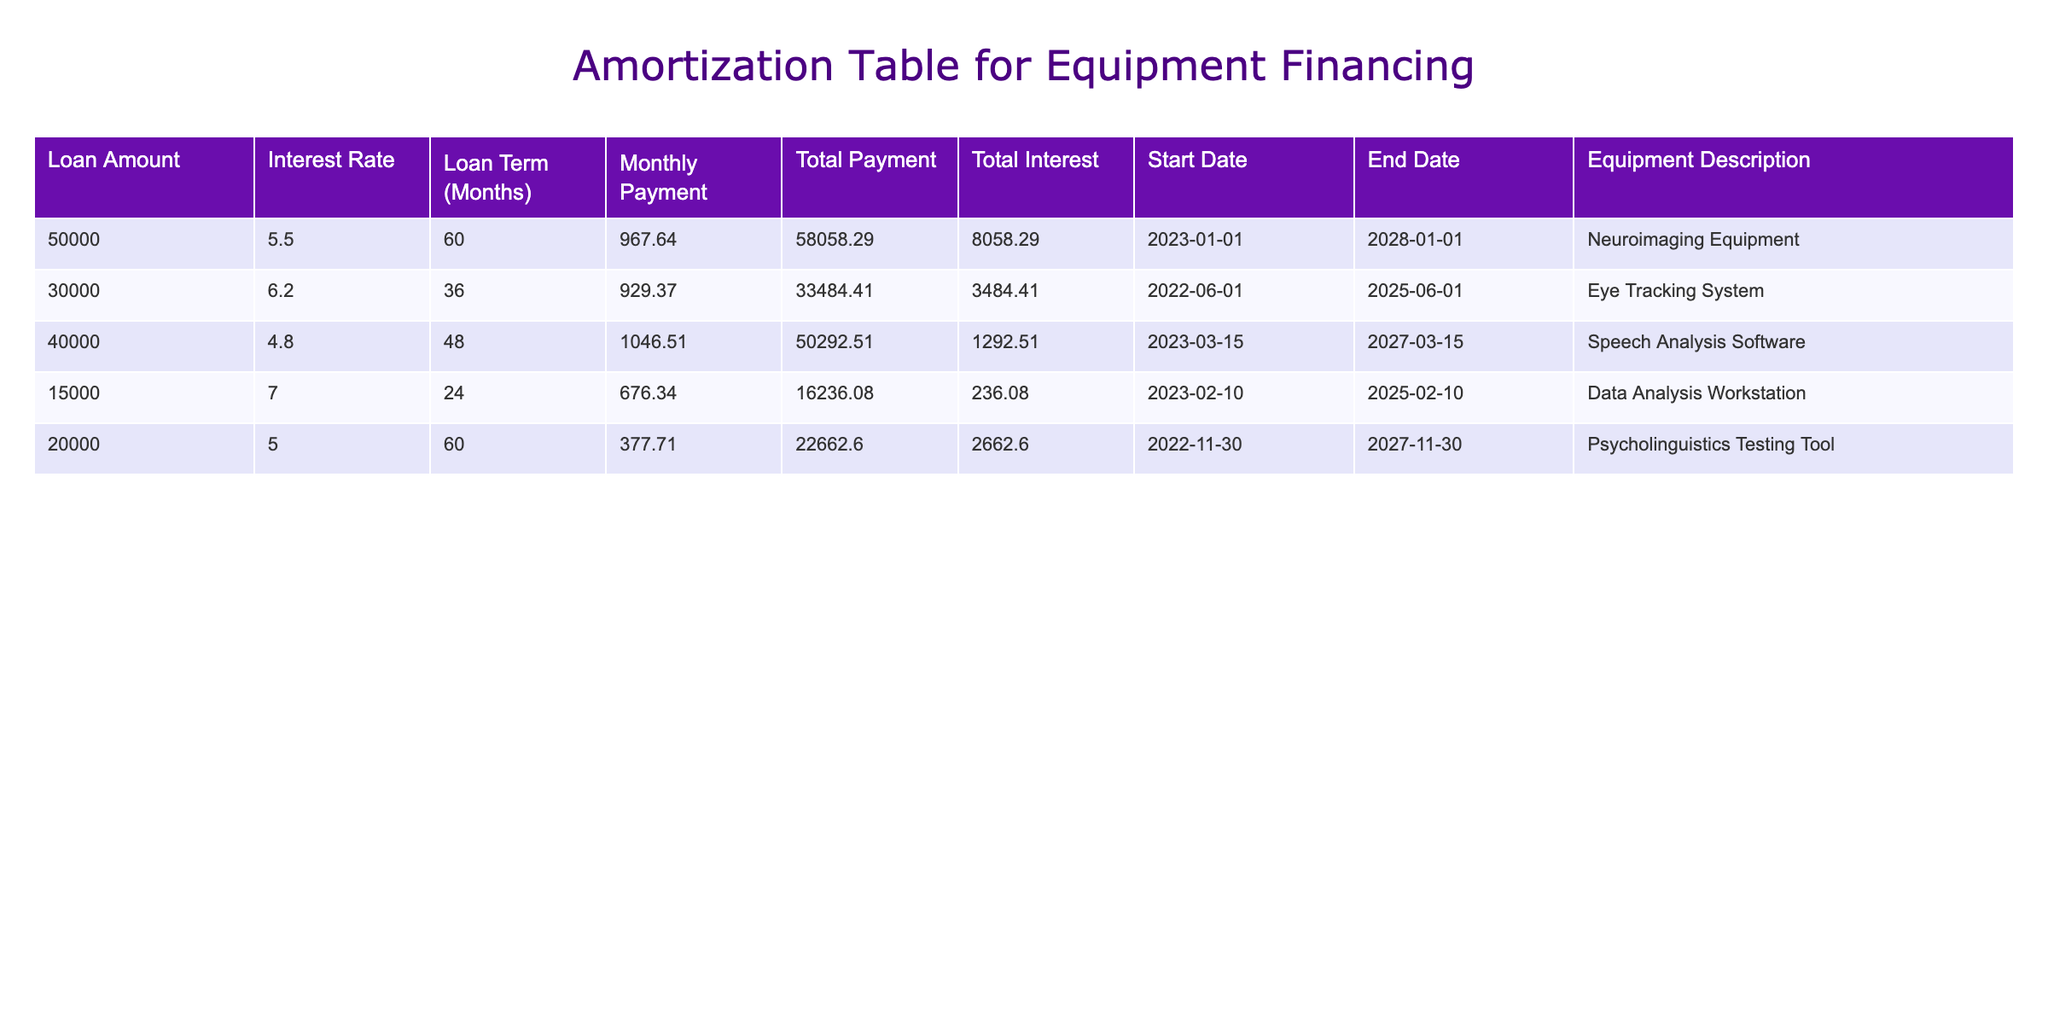What is the total payment for the Neuroimaging Equipment? The total payment for the Neuroimaging Equipment is clearly listed in the table under the "Total Payment" column. It shows a value of 58058.29.
Answer: 58058.29 What is the interest rate for the Eye Tracking System? The interest rate for the Eye Tracking System can be found directly in the table under the "Interest Rate" column, which is 6.2.
Answer: 6.2 Is the total interest for the Speech Analysis Software greater than 1000? The total interest for the Speech Analysis Software is listed in the table as 1292.51, which is indeed greater than 1000. Therefore, the statement is true.
Answer: Yes What is the monthly payment for the Data Analysis Workstation? The monthly payment for the Data Analysis Workstation is available in the "Monthly Payment" column of the table; it states a payment of 676.34.
Answer: 676.34 Combine the total payments for the Psycholinguistics Testing Tool and the Eye Tracking System. What is the result? The total payment for the Psycholinguistics Testing Tool is 22662.60 and for the Eye Tracking System is 33484.41. Adding these values gives 22662.60 + 33484.41 = 56147.01.
Answer: 56147.01 What is the average monthly payment for all listed equipment? To find the average monthly payment, we take the total of all monthly payments (967.64 + 929.37 + 1046.51 + 676.34 + 377.71 = 4097.57) and divide by the number of items (5). Thus, the average monthly payment is 4097.57 / 5 = 819.514.
Answer: 819.514 Which equipment has the longest loan term, and what is that term? Reviewing the "Loan Term (Months)" column, the Eye Tracking System has the longest loan term of 36 months since all other terms are shorter.
Answer: 36 Are there more than two pieces of equipment financed with an interest rate above 6%? In the data, only the Eye Tracking System (6.2) and the Data Analysis Workstation (7.0) have interest rates exceeding 6%. Therefore, the answer to this question is false, as there are exactly two items.
Answer: No How much total interest will be paid for the equipment labeled as "Neuroimaging Equipment"? The amount of total interest for the Neuroimaging Equipment is stated under "Total Interest," which is 8058.29. This is the amount that will be paid over the loan period.
Answer: 8058.29 